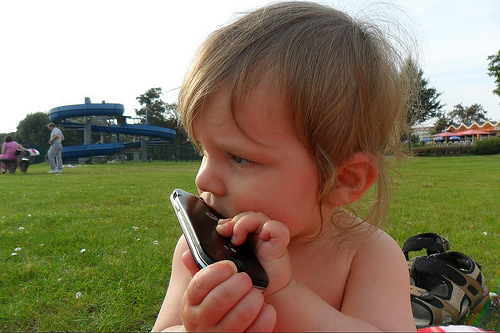What time of day does it appear to be? Given the brightness of the environment and the shadows cast on the grass, it seems to be daytime. The light appears soft, which could suggest either morning or late afternoon, typical times for enjoying outdoor activities, especially with young children. 